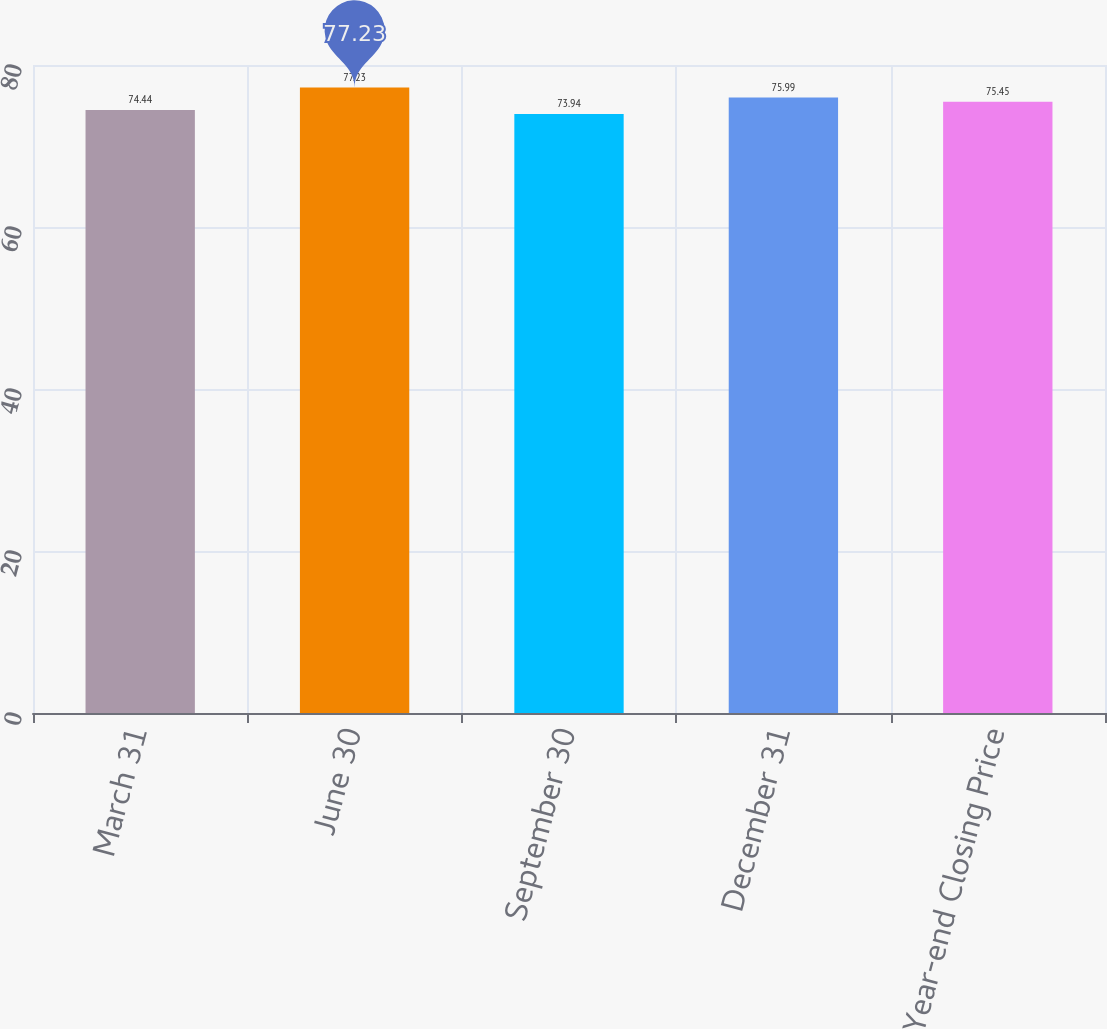<chart> <loc_0><loc_0><loc_500><loc_500><bar_chart><fcel>March 31<fcel>June 30<fcel>September 30<fcel>December 31<fcel>Year-end Closing Price<nl><fcel>74.44<fcel>77.23<fcel>73.94<fcel>75.99<fcel>75.45<nl></chart> 